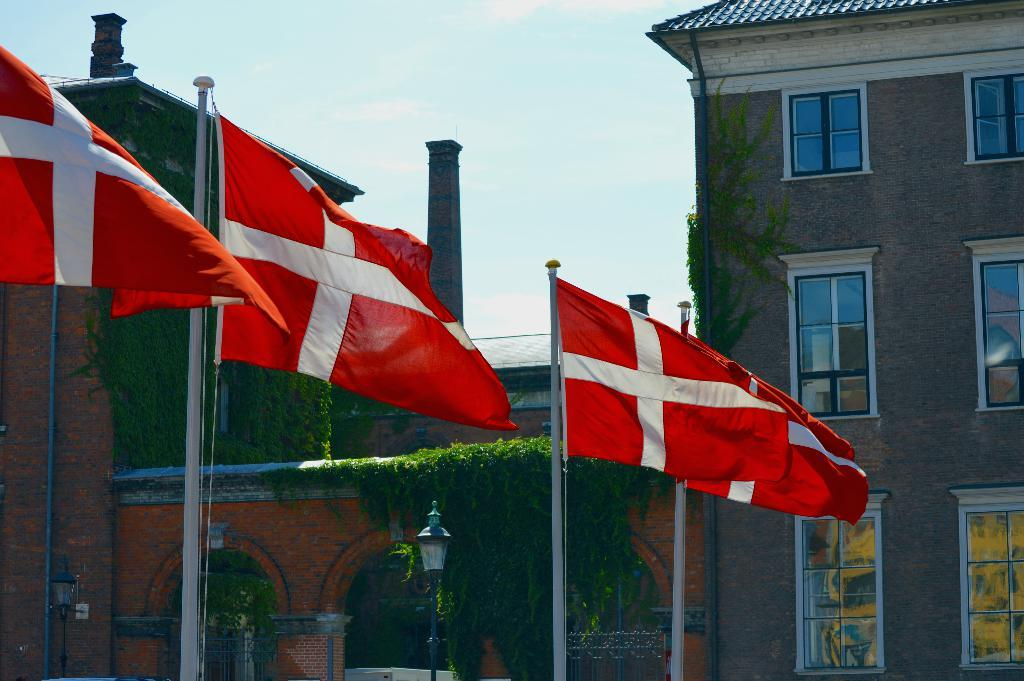What colors are the flags in the image? The flags in the image are red and white. What can be seen in the background of the image? In the background of the image, there are light poles, a building with windows, plants, and the sky. Can you describe the building in the background? The building in the background has windows. What type of vegetation is present in the background? There are plants in the background of the image. What degree does the friend in the image have? There is no friend present in the image, so it is not possible to determine their degree. 